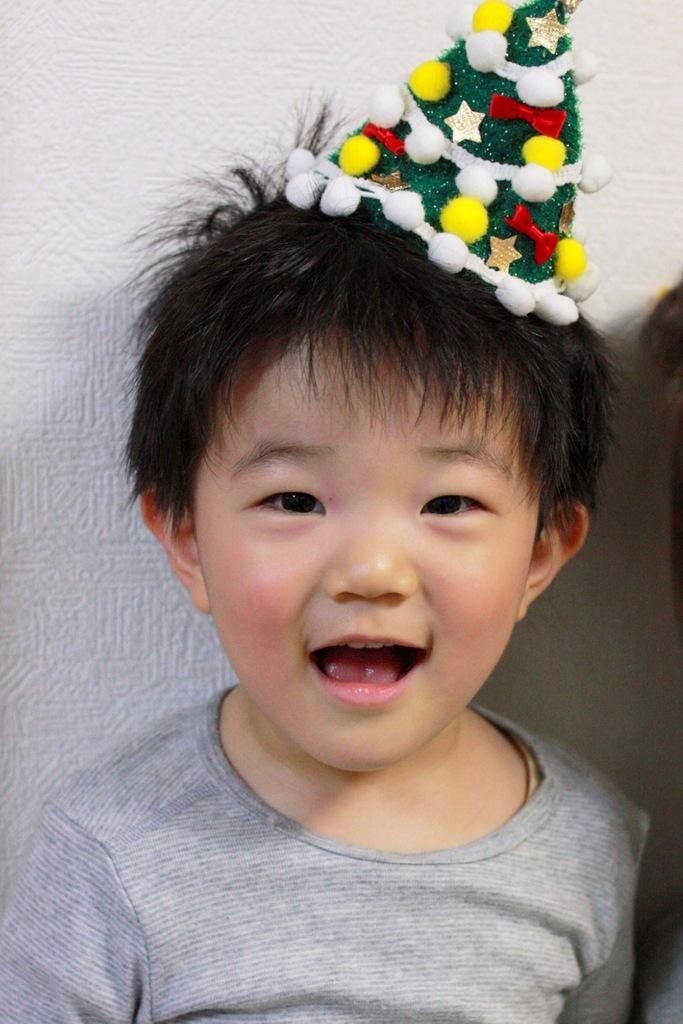Who is the main subject in the picture? The main subject in the picture is a child. What is the child doing in the picture? The child is present over a place and is smiling. What is the child wearing in the picture? The child is wearing a birthday cap. Can you see the child's father in the picture? There is no mention of the child's father in the provided facts, so it cannot be determined if the father is present in the image. 